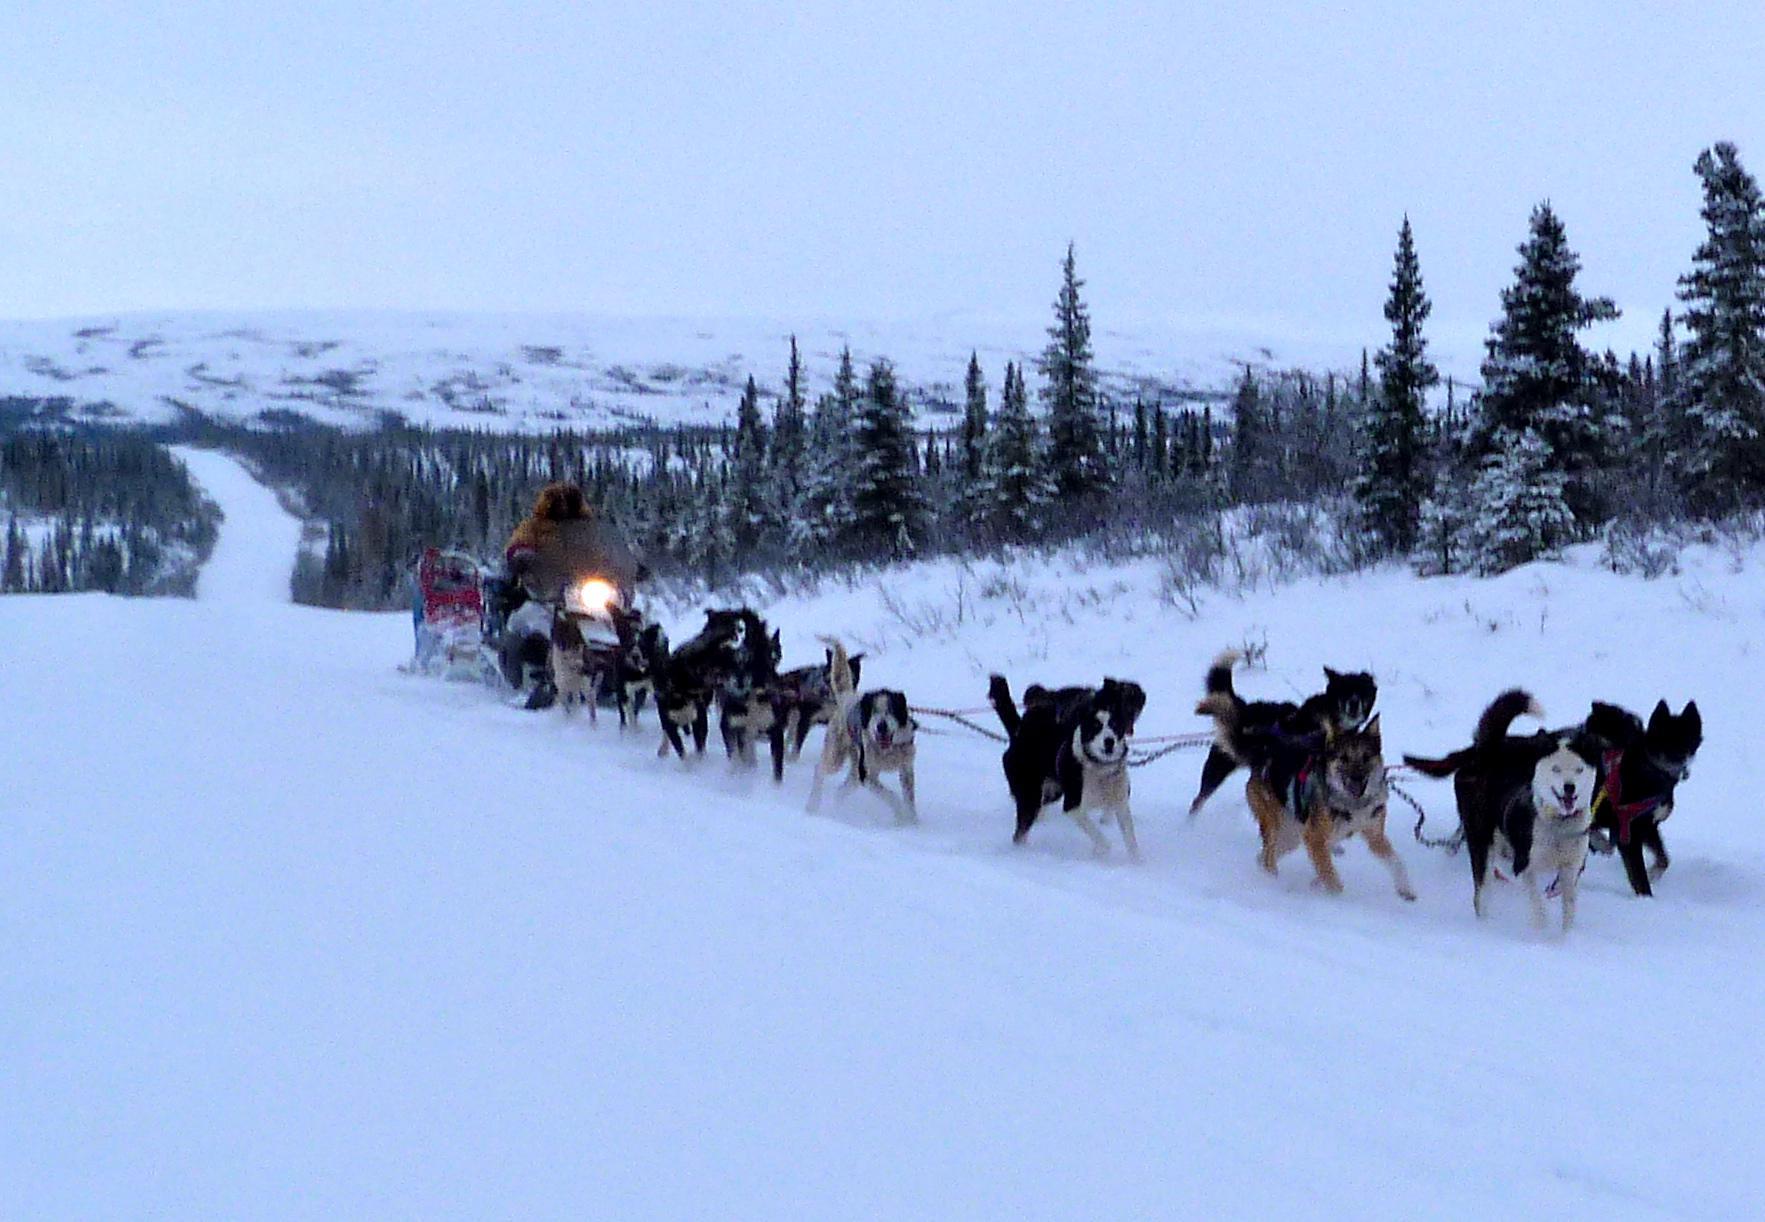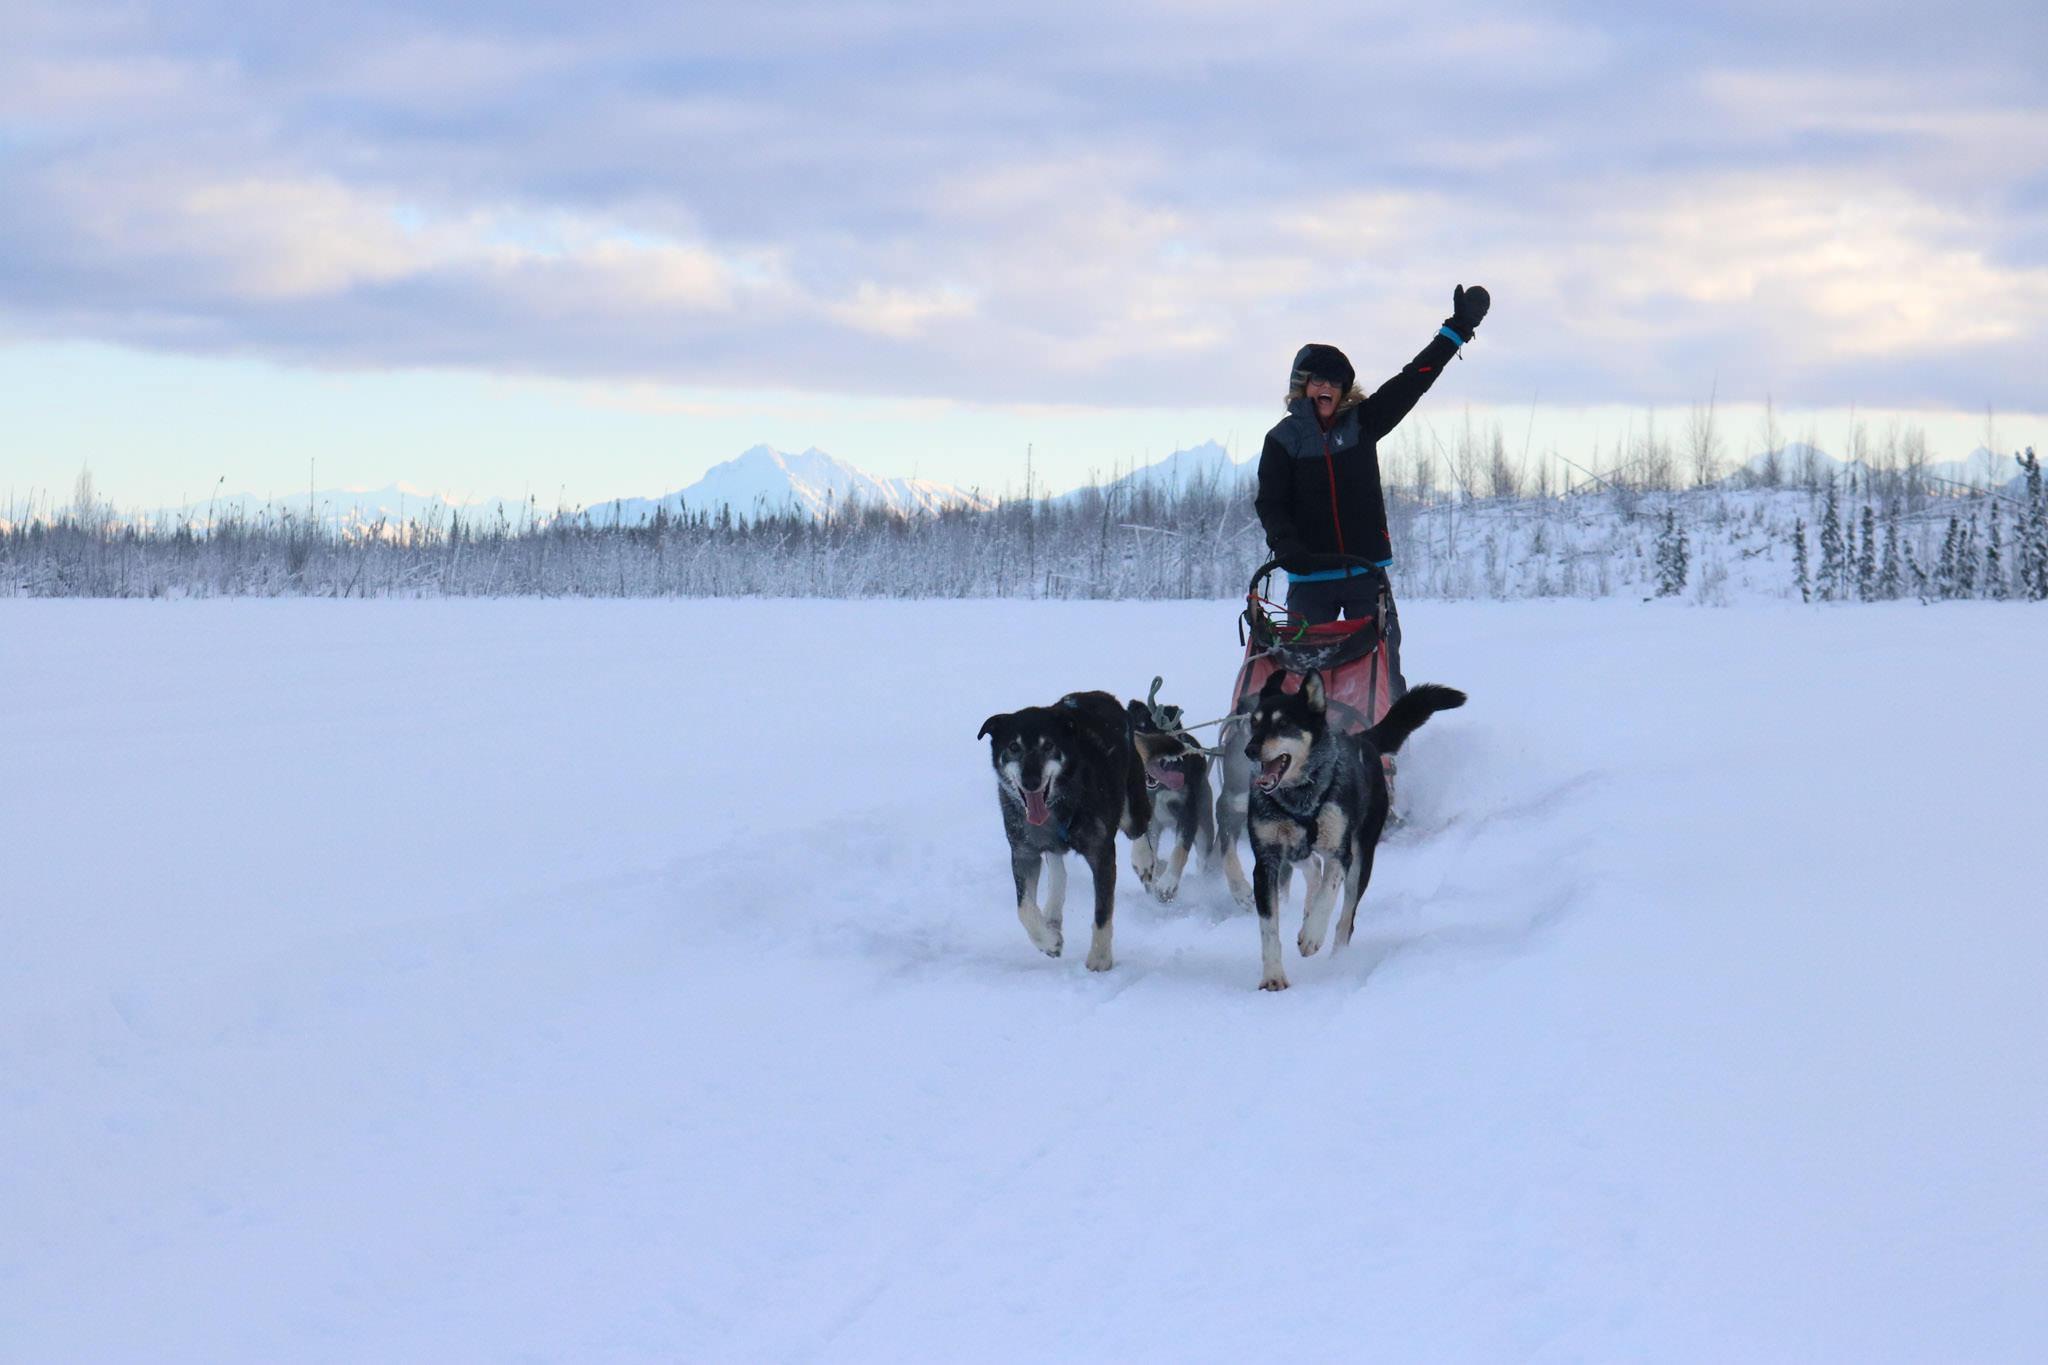The first image is the image on the left, the second image is the image on the right. Assess this claim about the two images: "The dog sled teams in the left and right images move forward at some angle and appear to be heading toward each other.". Correct or not? Answer yes or no. Yes. The first image is the image on the left, the second image is the image on the right. For the images shown, is this caption "The dogs in the left image are heading to the right." true? Answer yes or no. Yes. 